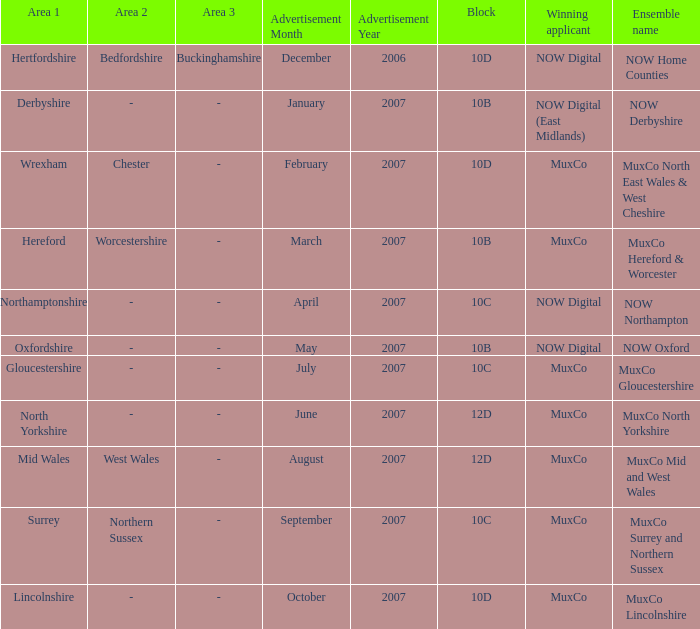What is Ensemble Name Muxco Gloucestershire's Advertisement Date in Block 10C? July 2007. 